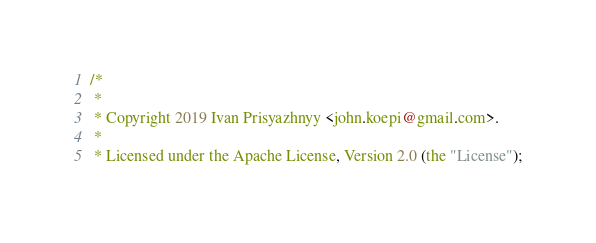<code> <loc_0><loc_0><loc_500><loc_500><_Go_>/*
 *
 * Copyright 2019 Ivan Prisyazhnyy <john.koepi@gmail.com>.
 *
 * Licensed under the Apache License, Version 2.0 (the "License");</code> 